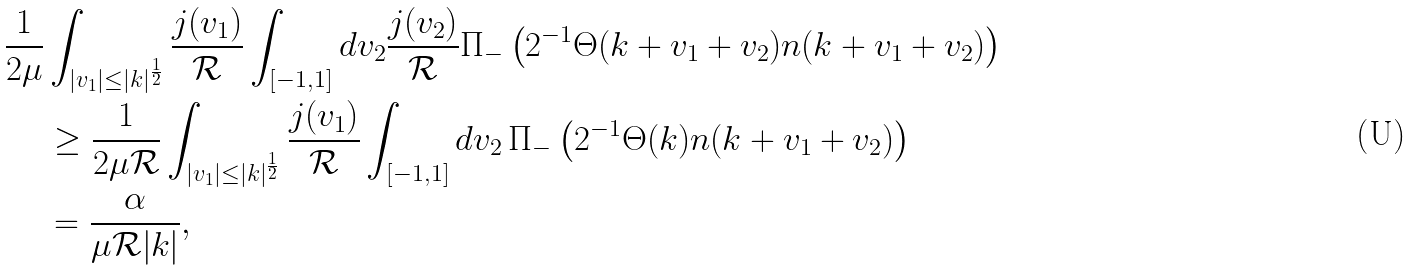Convert formula to latex. <formula><loc_0><loc_0><loc_500><loc_500>\frac { 1 } { 2 \mu } & \int _ { | v _ { 1 } | \leq | k | ^ { \frac { 1 } { 2 } } } \frac { j ( v _ { 1 } ) } { \mathcal { R } } \int _ { [ - 1 , 1 ] } d v _ { 2 } \frac { j ( v _ { 2 } ) } { \mathcal { R } } \Pi _ { - } \left ( 2 ^ { - 1 } \Theta ( k + v _ { 1 } + v _ { 2 } ) n ( k + v _ { 1 } + v _ { 2 } ) \right ) \\ & \geq \frac { 1 } { 2 \mu \mathcal { R } } \int _ { | v _ { 1 } | \leq | k | ^ { \frac { 1 } { 2 } } } \frac { j ( v _ { 1 } ) } { \mathcal { R } } \int _ { [ - 1 , 1 ] } d v _ { 2 } \, \Pi _ { - } \left ( 2 ^ { - 1 } \Theta ( k ) n ( k + v _ { 1 } + v _ { 2 } ) \right ) \\ & = \frac { \alpha } { \mu \mathcal { R } | k | } ,</formula> 